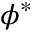Convert formula to latex. <formula><loc_0><loc_0><loc_500><loc_500>\phi ^ { * }</formula> 